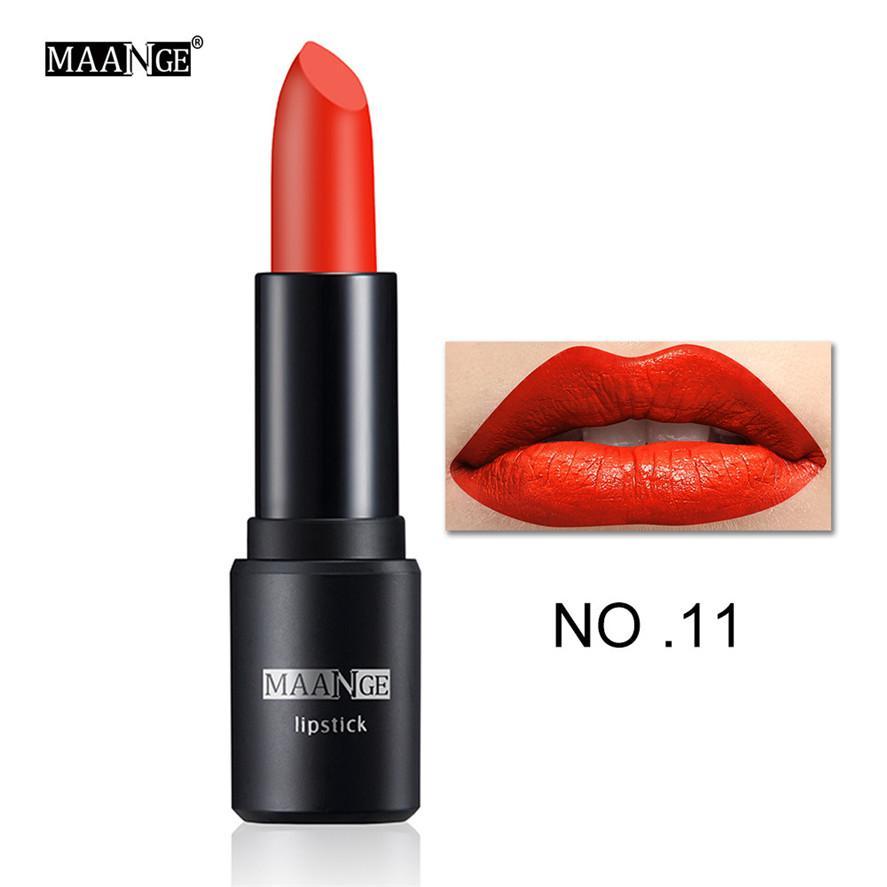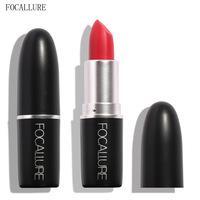The first image is the image on the left, the second image is the image on the right. Examine the images to the left and right. Is the description "An image shows one pair of painted lips to the right of a single lip makeup product." accurate? Answer yes or no. Yes. The first image is the image on the left, the second image is the image on the right. Considering the images on both sides, is "Exactly two lipsticks are shown, one of them capped, but with a lip photo display, while the other is open with the lipstick extended." valid? Answer yes or no. No. 